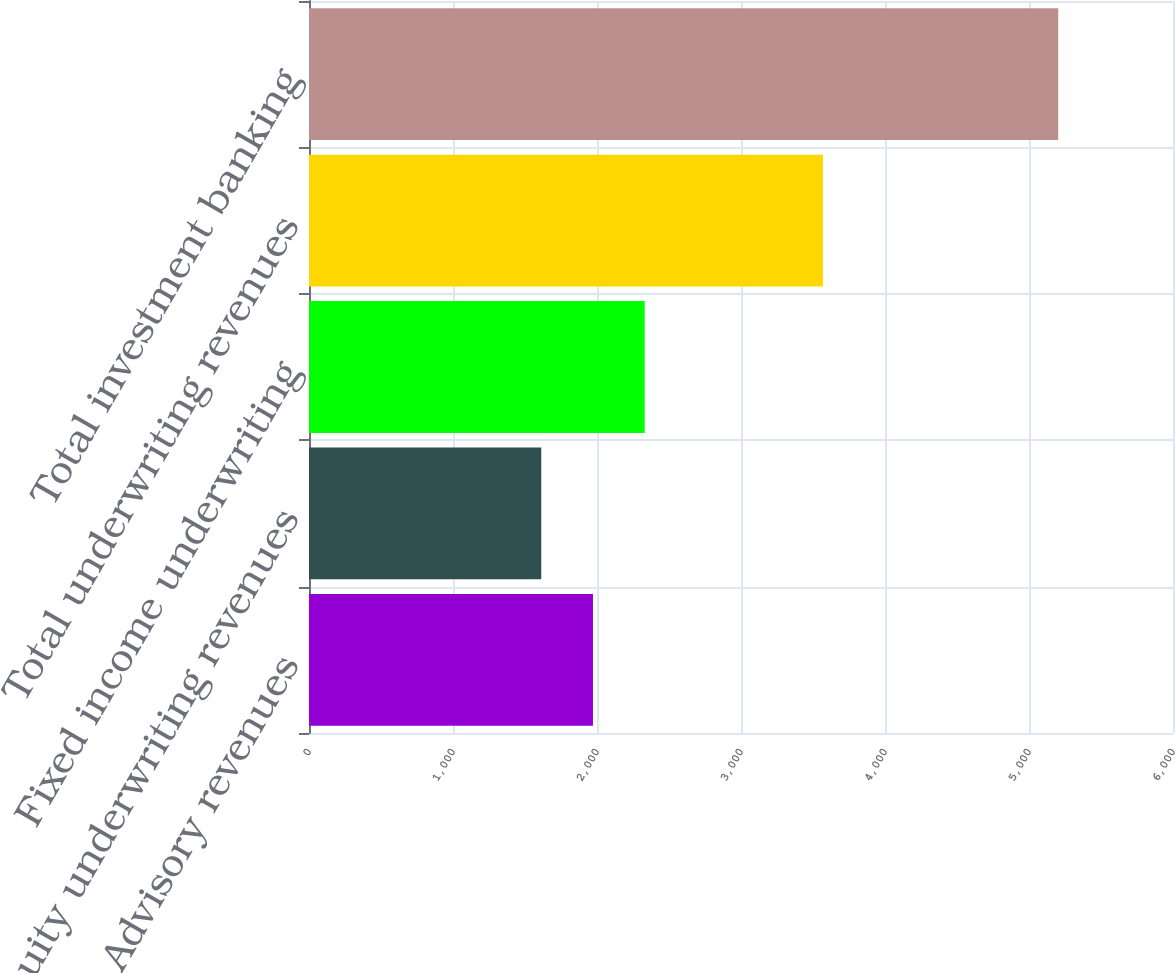<chart> <loc_0><loc_0><loc_500><loc_500><bar_chart><fcel>Advisory revenues<fcel>Equity underwriting revenues<fcel>Fixed income underwriting<fcel>Total underwriting revenues<fcel>Total investment banking<nl><fcel>1972<fcel>1613<fcel>2331<fcel>3569<fcel>5203<nl></chart> 